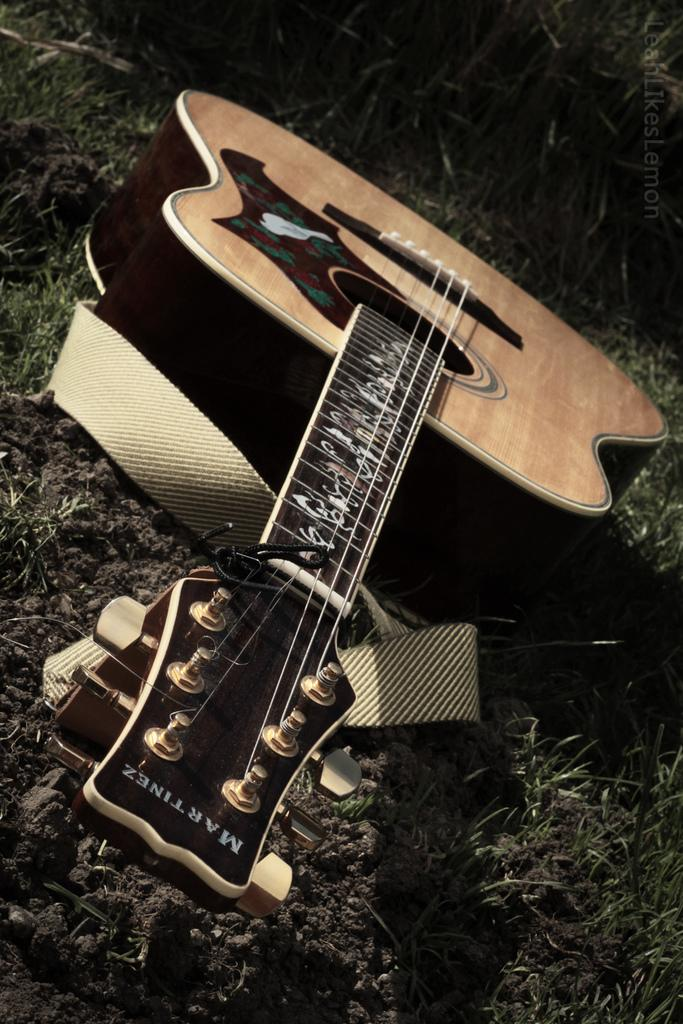What is depicted in the image? There is a picture of a guitar in the image. Where is the picture of the guitar located? The picture of the guitar is on the floor. What type of planes can be seen flying over the guitar in the image? There are no planes visible in the image; it only features a picture of a guitar on the floor. What material is the deer made of in the image? There is no deer present in the image, so it is not possible to determine the material it might be made of. 